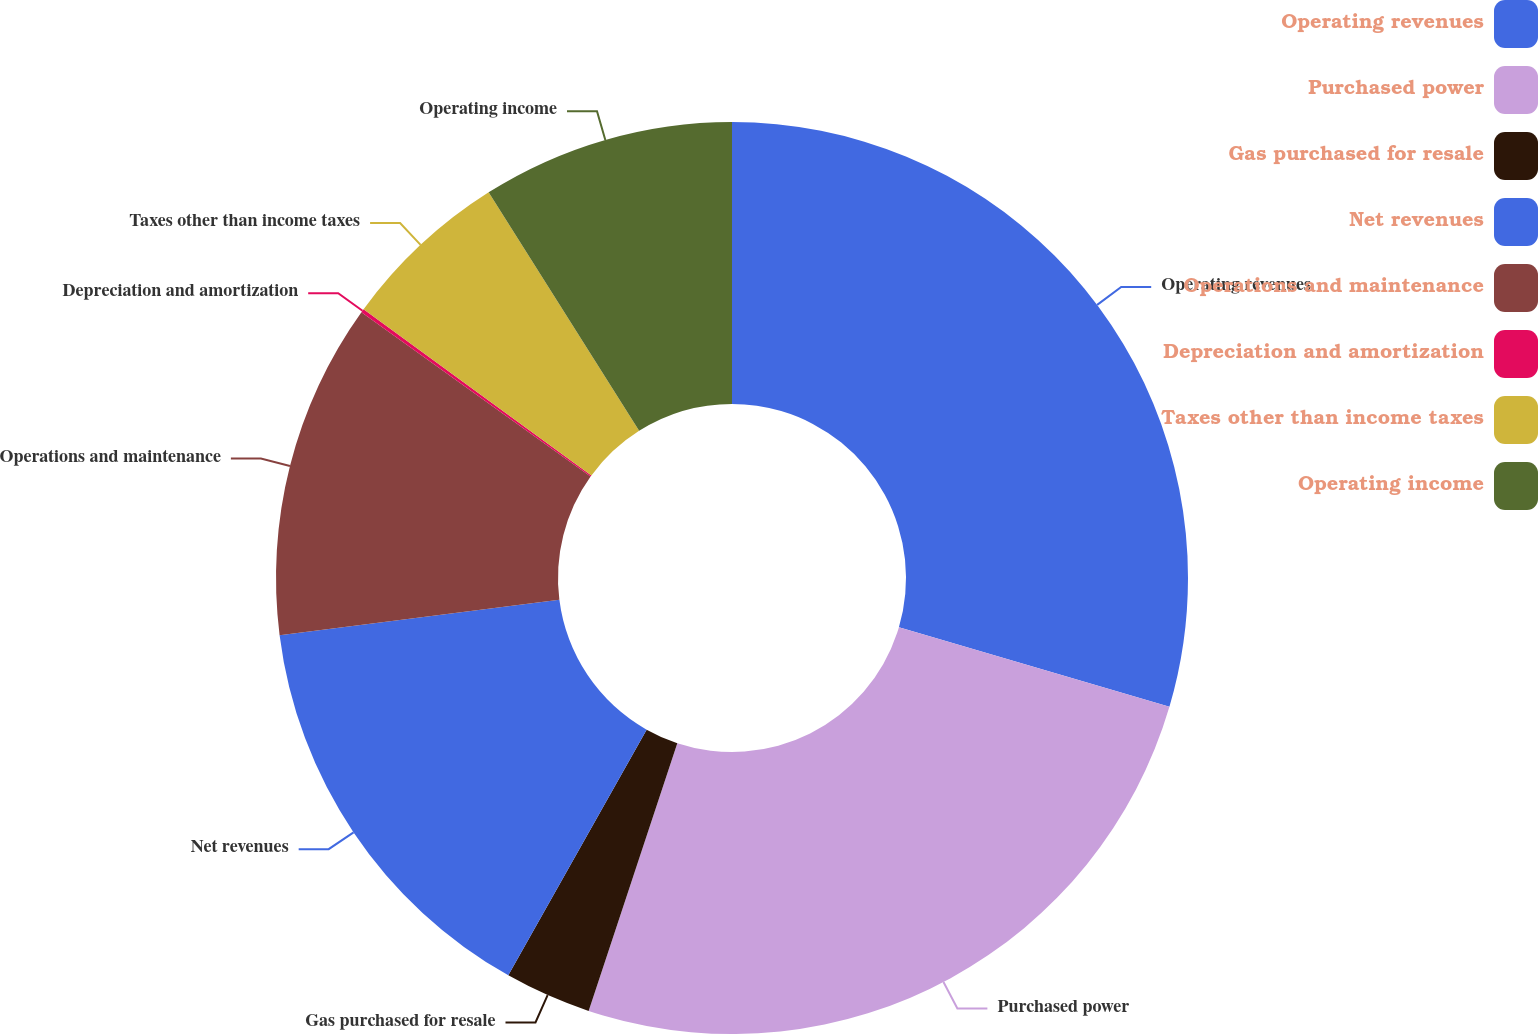<chart> <loc_0><loc_0><loc_500><loc_500><pie_chart><fcel>Operating revenues<fcel>Purchased power<fcel>Gas purchased for resale<fcel>Net revenues<fcel>Operations and maintenance<fcel>Depreciation and amortization<fcel>Taxes other than income taxes<fcel>Operating income<nl><fcel>29.56%<fcel>25.53%<fcel>3.07%<fcel>14.84%<fcel>11.9%<fcel>0.13%<fcel>6.01%<fcel>8.96%<nl></chart> 